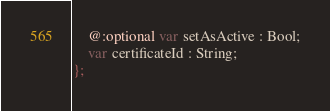Convert code to text. <code><loc_0><loc_0><loc_500><loc_500><_Haxe_>    @:optional var setAsActive : Bool;
    var certificateId : String;
};
</code> 